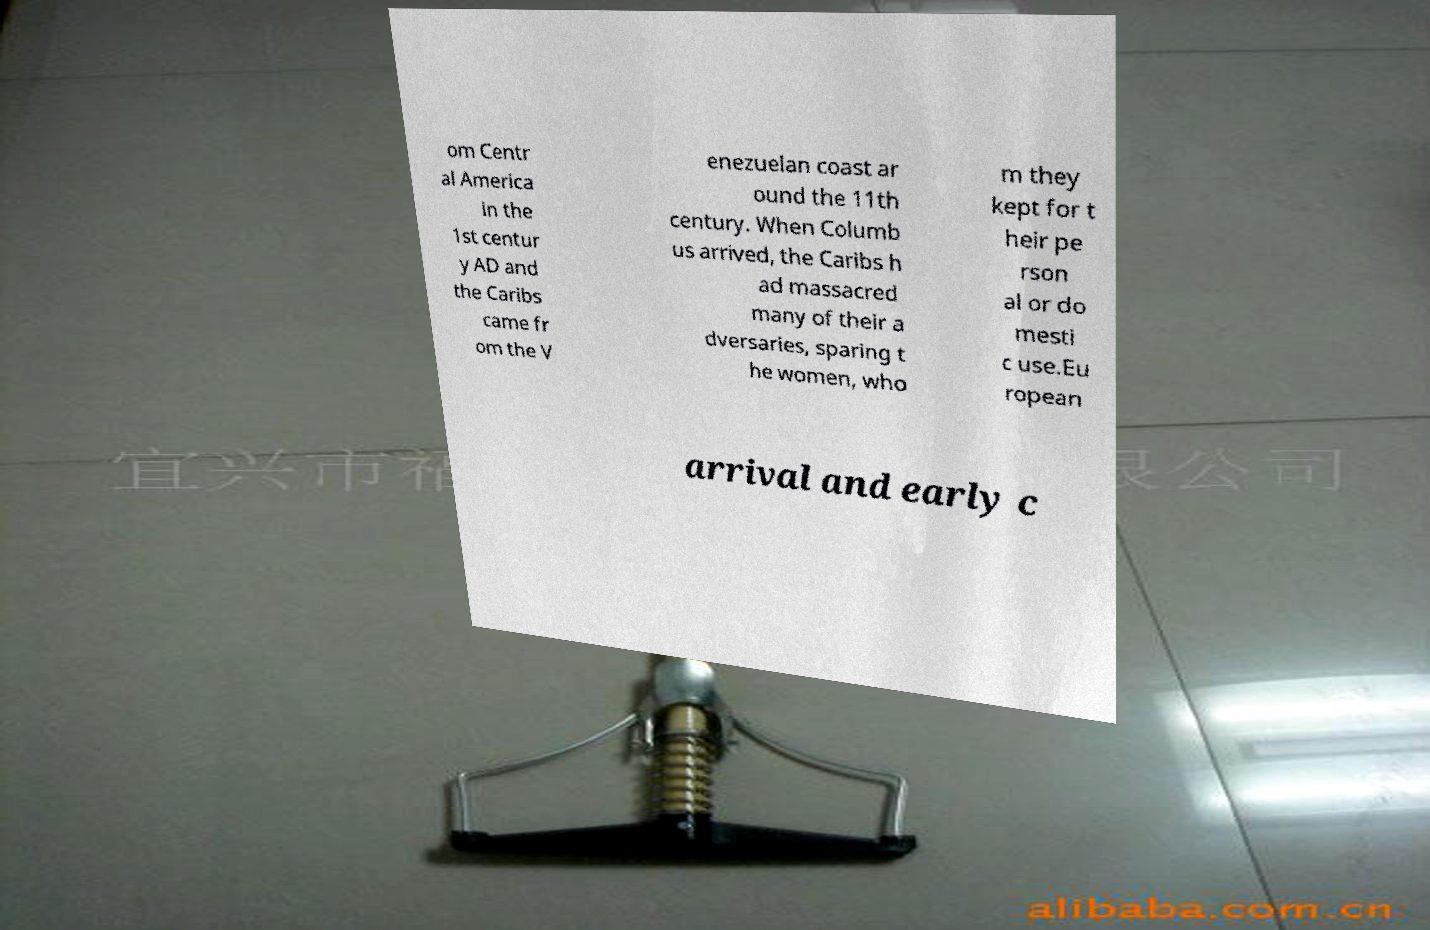There's text embedded in this image that I need extracted. Can you transcribe it verbatim? om Centr al America in the 1st centur y AD and the Caribs came fr om the V enezuelan coast ar ound the 11th century. When Columb us arrived, the Caribs h ad massacred many of their a dversaries, sparing t he women, who m they kept for t heir pe rson al or do mesti c use.Eu ropean arrival and early c 